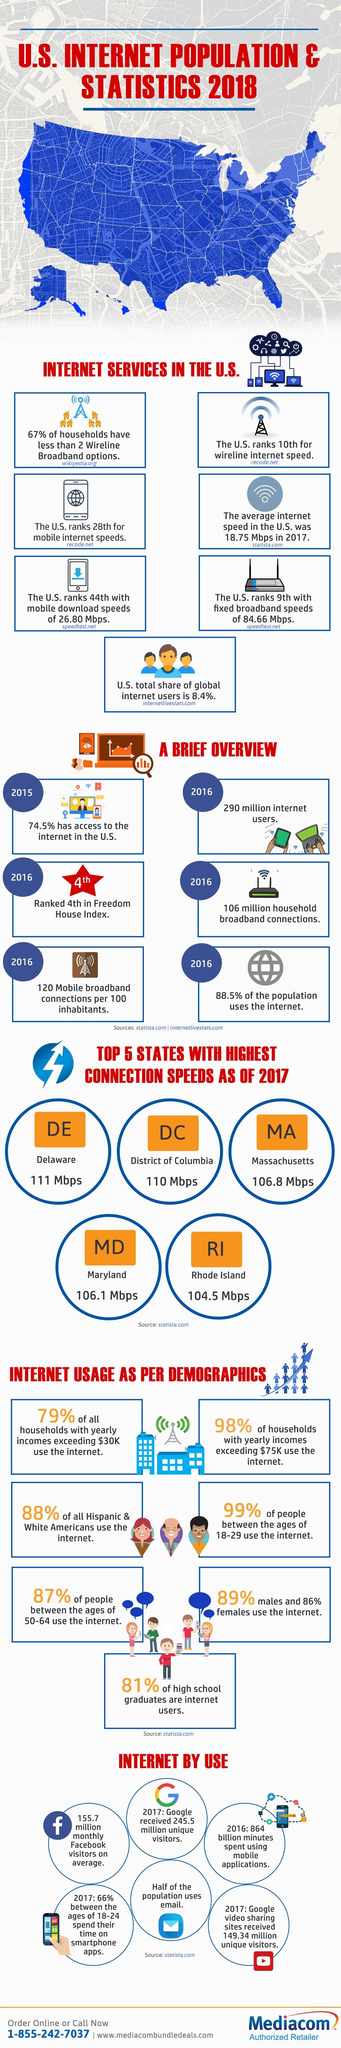What is the highest broadband connection speed available in the U.S. as of 2017?
Answer the question with a short phrase. 111 Mbps What percentage of high school graduates in the U.S. do not use internet in 2018? 19% What is the population of internet users in the U.S. in 2016? 290 million What is the total household broadband connections available in the U.S. in 2016? 106 million What is the broadband internet connection speed in the Massachusetts as of 2017? 106.8 Mbps What is the broadband internet connection speed in the District of Columbia as of 2017? 110 Mbps What percentage of people in the U.S. do not have access to the internet in 2015? 25.5% Which state in the U.S. has the highest connection speed as of 2017? Delaware What percentage of U.S. population do not use internet in 2016? 11.5% Which state in the U.S. has the second highest connection speed as of 2017? District of Columbia 